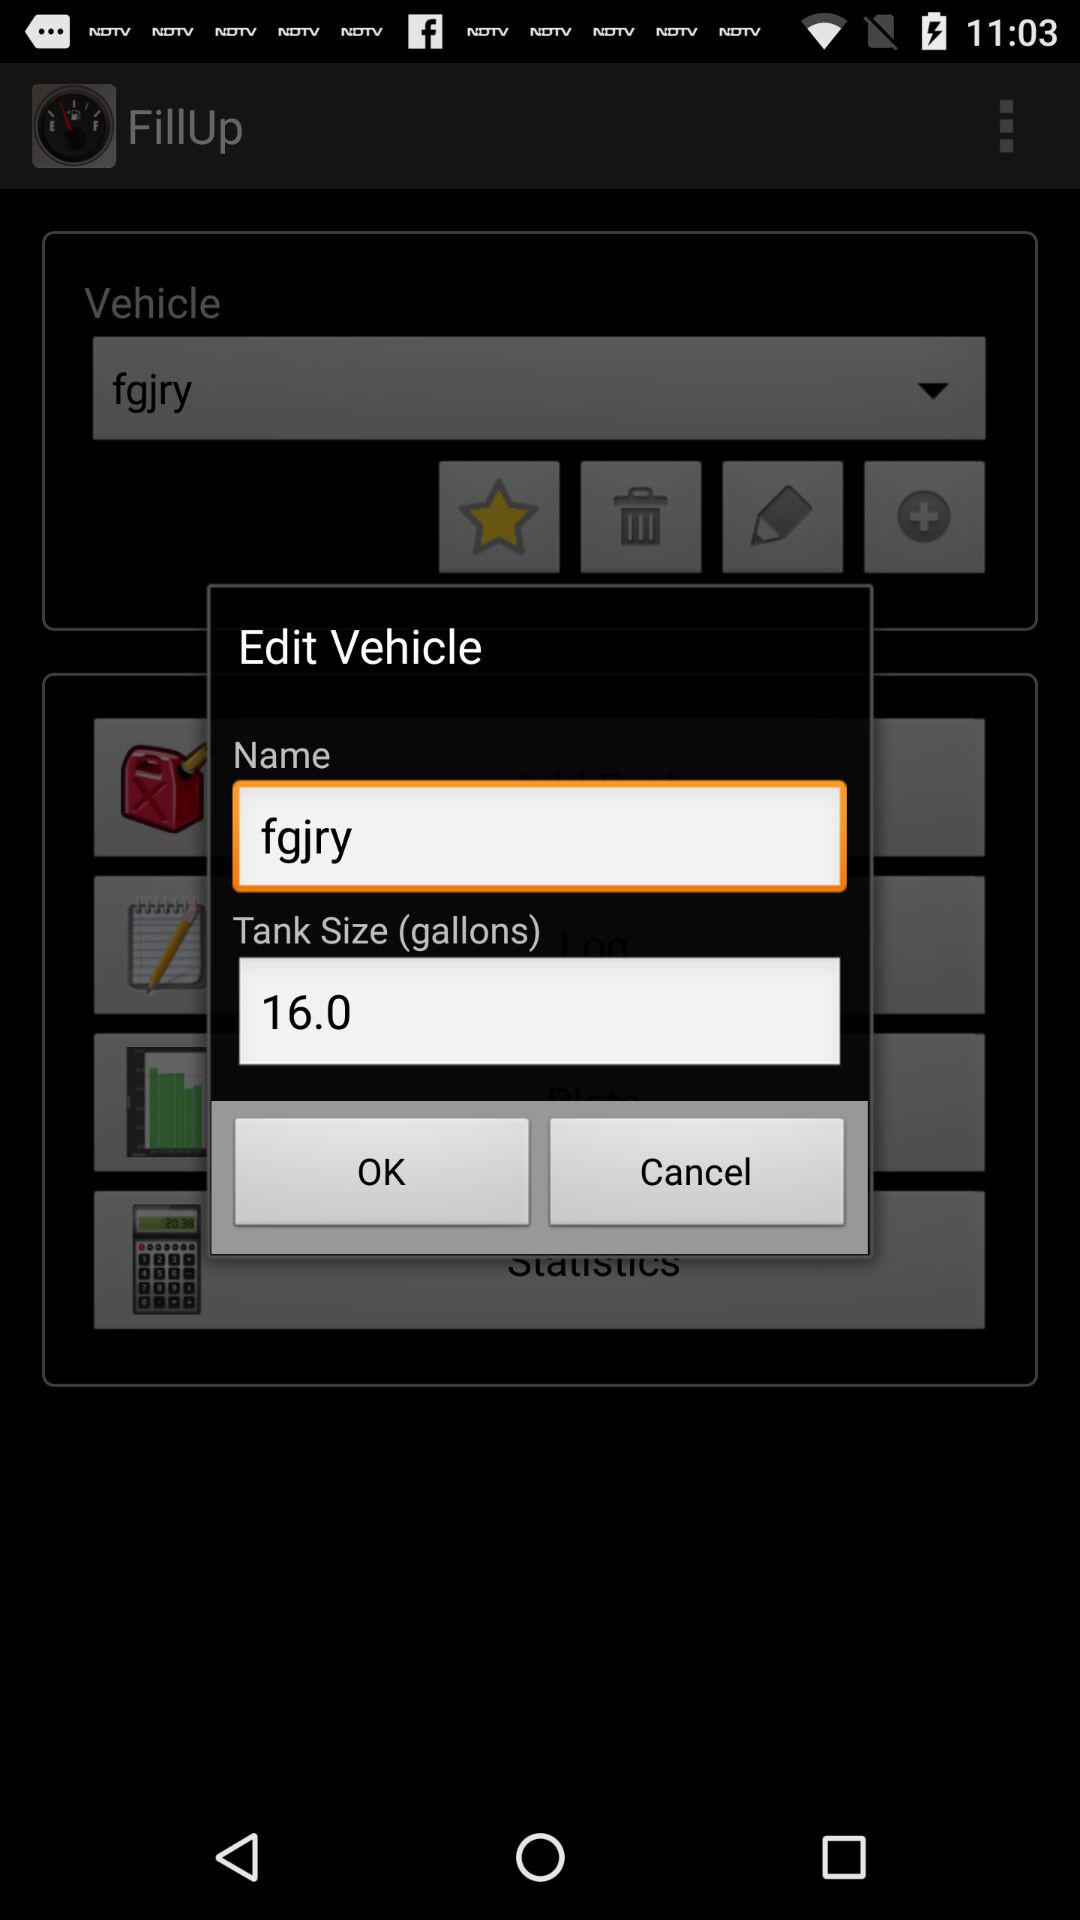What is the vehicle name? The vehicle name is "fgjry". 